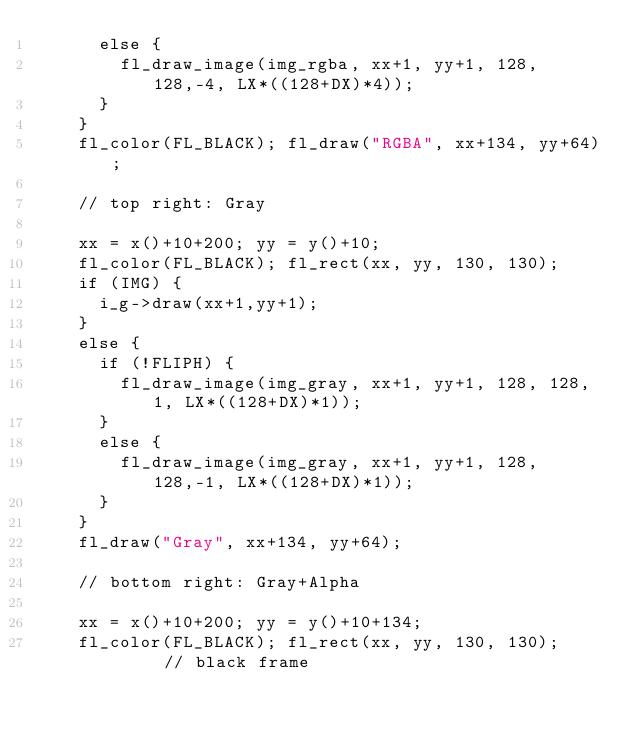Convert code to text. <code><loc_0><loc_0><loc_500><loc_500><_C++_>      else {
        fl_draw_image(img_rgba, xx+1, yy+1, 128, 128,-4, LX*((128+DX)*4));
      }
    }
    fl_color(FL_BLACK); fl_draw("RGBA", xx+134, yy+64);

    // top right: Gray

    xx = x()+10+200; yy = y()+10;
    fl_color(FL_BLACK); fl_rect(xx, yy, 130, 130);
    if (IMG) {
      i_g->draw(xx+1,yy+1);
    }
    else {
      if (!FLIPH) {
        fl_draw_image(img_gray, xx+1, yy+1, 128, 128, 1, LX*((128+DX)*1));
      }
      else {
        fl_draw_image(img_gray, xx+1, yy+1, 128, 128,-1, LX*((128+DX)*1));
      }
    }
    fl_draw("Gray", xx+134, yy+64);

    // bottom right: Gray+Alpha

    xx = x()+10+200; yy = y()+10+134;
    fl_color(FL_BLACK); fl_rect(xx, yy, 130, 130);      // black frame</code> 